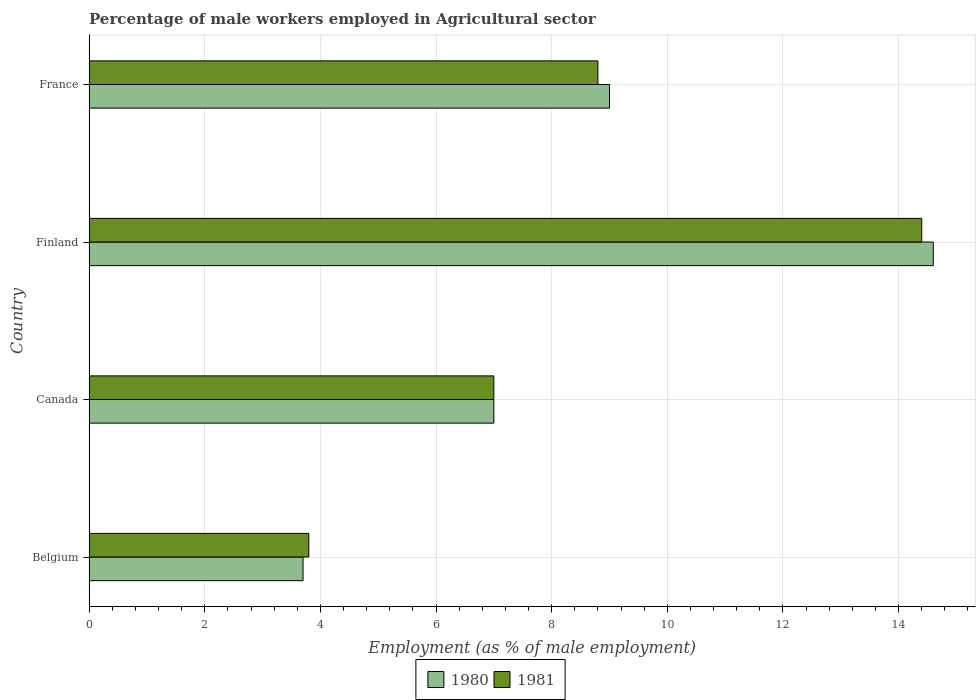Are the number of bars per tick equal to the number of legend labels?
Your response must be concise. Yes. Are the number of bars on each tick of the Y-axis equal?
Provide a short and direct response. Yes. How many bars are there on the 3rd tick from the top?
Keep it short and to the point. 2. What is the label of the 3rd group of bars from the top?
Offer a very short reply. Canada. In how many cases, is the number of bars for a given country not equal to the number of legend labels?
Provide a succinct answer. 0. What is the percentage of male workers employed in Agricultural sector in 1981 in Belgium?
Offer a very short reply. 3.8. Across all countries, what is the maximum percentage of male workers employed in Agricultural sector in 1980?
Your response must be concise. 14.6. Across all countries, what is the minimum percentage of male workers employed in Agricultural sector in 1981?
Ensure brevity in your answer.  3.8. In which country was the percentage of male workers employed in Agricultural sector in 1981 maximum?
Offer a very short reply. Finland. In which country was the percentage of male workers employed in Agricultural sector in 1980 minimum?
Your response must be concise. Belgium. What is the total percentage of male workers employed in Agricultural sector in 1981 in the graph?
Provide a short and direct response. 34. What is the difference between the percentage of male workers employed in Agricultural sector in 1981 in Canada and that in France?
Provide a succinct answer. -1.8. What is the difference between the percentage of male workers employed in Agricultural sector in 1980 in Finland and the percentage of male workers employed in Agricultural sector in 1981 in Canada?
Ensure brevity in your answer.  7.6. What is the average percentage of male workers employed in Agricultural sector in 1981 per country?
Provide a short and direct response. 8.5. What is the ratio of the percentage of male workers employed in Agricultural sector in 1980 in Belgium to that in Finland?
Ensure brevity in your answer.  0.25. Is the difference between the percentage of male workers employed in Agricultural sector in 1981 in Belgium and Canada greater than the difference between the percentage of male workers employed in Agricultural sector in 1980 in Belgium and Canada?
Offer a very short reply. Yes. What is the difference between the highest and the second highest percentage of male workers employed in Agricultural sector in 1981?
Ensure brevity in your answer.  5.6. What is the difference between the highest and the lowest percentage of male workers employed in Agricultural sector in 1981?
Your response must be concise. 10.6. Is the sum of the percentage of male workers employed in Agricultural sector in 1980 in Belgium and France greater than the maximum percentage of male workers employed in Agricultural sector in 1981 across all countries?
Provide a succinct answer. No. How many countries are there in the graph?
Your response must be concise. 4. Does the graph contain any zero values?
Keep it short and to the point. No. Does the graph contain grids?
Offer a terse response. Yes. How many legend labels are there?
Your response must be concise. 2. What is the title of the graph?
Ensure brevity in your answer.  Percentage of male workers employed in Agricultural sector. Does "1983" appear as one of the legend labels in the graph?
Provide a short and direct response. No. What is the label or title of the X-axis?
Provide a short and direct response. Employment (as % of male employment). What is the Employment (as % of male employment) in 1980 in Belgium?
Keep it short and to the point. 3.7. What is the Employment (as % of male employment) of 1981 in Belgium?
Make the answer very short. 3.8. What is the Employment (as % of male employment) in 1980 in Canada?
Your response must be concise. 7. What is the Employment (as % of male employment) in 1981 in Canada?
Ensure brevity in your answer.  7. What is the Employment (as % of male employment) in 1980 in Finland?
Offer a very short reply. 14.6. What is the Employment (as % of male employment) in 1981 in Finland?
Give a very brief answer. 14.4. What is the Employment (as % of male employment) in 1981 in France?
Ensure brevity in your answer.  8.8. Across all countries, what is the maximum Employment (as % of male employment) of 1980?
Make the answer very short. 14.6. Across all countries, what is the maximum Employment (as % of male employment) of 1981?
Your answer should be very brief. 14.4. Across all countries, what is the minimum Employment (as % of male employment) in 1980?
Your response must be concise. 3.7. Across all countries, what is the minimum Employment (as % of male employment) in 1981?
Provide a succinct answer. 3.8. What is the total Employment (as % of male employment) in 1980 in the graph?
Keep it short and to the point. 34.3. What is the total Employment (as % of male employment) in 1981 in the graph?
Your response must be concise. 34. What is the difference between the Employment (as % of male employment) in 1981 in Belgium and that in Canada?
Provide a succinct answer. -3.2. What is the difference between the Employment (as % of male employment) in 1980 in Belgium and that in Finland?
Offer a terse response. -10.9. What is the difference between the Employment (as % of male employment) of 1981 in Belgium and that in Finland?
Offer a very short reply. -10.6. What is the difference between the Employment (as % of male employment) in 1981 in Belgium and that in France?
Your answer should be compact. -5. What is the difference between the Employment (as % of male employment) in 1981 in Canada and that in France?
Your answer should be very brief. -1.8. What is the difference between the Employment (as % of male employment) of 1981 in Finland and that in France?
Your answer should be compact. 5.6. What is the difference between the Employment (as % of male employment) in 1980 in Belgium and the Employment (as % of male employment) in 1981 in Finland?
Offer a terse response. -10.7. What is the difference between the Employment (as % of male employment) of 1980 in Belgium and the Employment (as % of male employment) of 1981 in France?
Keep it short and to the point. -5.1. What is the difference between the Employment (as % of male employment) in 1980 in Canada and the Employment (as % of male employment) in 1981 in France?
Offer a terse response. -1.8. What is the difference between the Employment (as % of male employment) of 1980 in Finland and the Employment (as % of male employment) of 1981 in France?
Your response must be concise. 5.8. What is the average Employment (as % of male employment) of 1980 per country?
Your answer should be very brief. 8.57. What is the ratio of the Employment (as % of male employment) in 1980 in Belgium to that in Canada?
Give a very brief answer. 0.53. What is the ratio of the Employment (as % of male employment) in 1981 in Belgium to that in Canada?
Your answer should be very brief. 0.54. What is the ratio of the Employment (as % of male employment) in 1980 in Belgium to that in Finland?
Keep it short and to the point. 0.25. What is the ratio of the Employment (as % of male employment) in 1981 in Belgium to that in Finland?
Keep it short and to the point. 0.26. What is the ratio of the Employment (as % of male employment) of 1980 in Belgium to that in France?
Give a very brief answer. 0.41. What is the ratio of the Employment (as % of male employment) in 1981 in Belgium to that in France?
Make the answer very short. 0.43. What is the ratio of the Employment (as % of male employment) in 1980 in Canada to that in Finland?
Your response must be concise. 0.48. What is the ratio of the Employment (as % of male employment) of 1981 in Canada to that in Finland?
Keep it short and to the point. 0.49. What is the ratio of the Employment (as % of male employment) in 1981 in Canada to that in France?
Ensure brevity in your answer.  0.8. What is the ratio of the Employment (as % of male employment) in 1980 in Finland to that in France?
Provide a short and direct response. 1.62. What is the ratio of the Employment (as % of male employment) in 1981 in Finland to that in France?
Ensure brevity in your answer.  1.64. What is the difference between the highest and the second highest Employment (as % of male employment) in 1980?
Your answer should be compact. 5.6. What is the difference between the highest and the lowest Employment (as % of male employment) in 1980?
Offer a very short reply. 10.9. What is the difference between the highest and the lowest Employment (as % of male employment) in 1981?
Offer a very short reply. 10.6. 